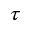<formula> <loc_0><loc_0><loc_500><loc_500>\tau</formula> 